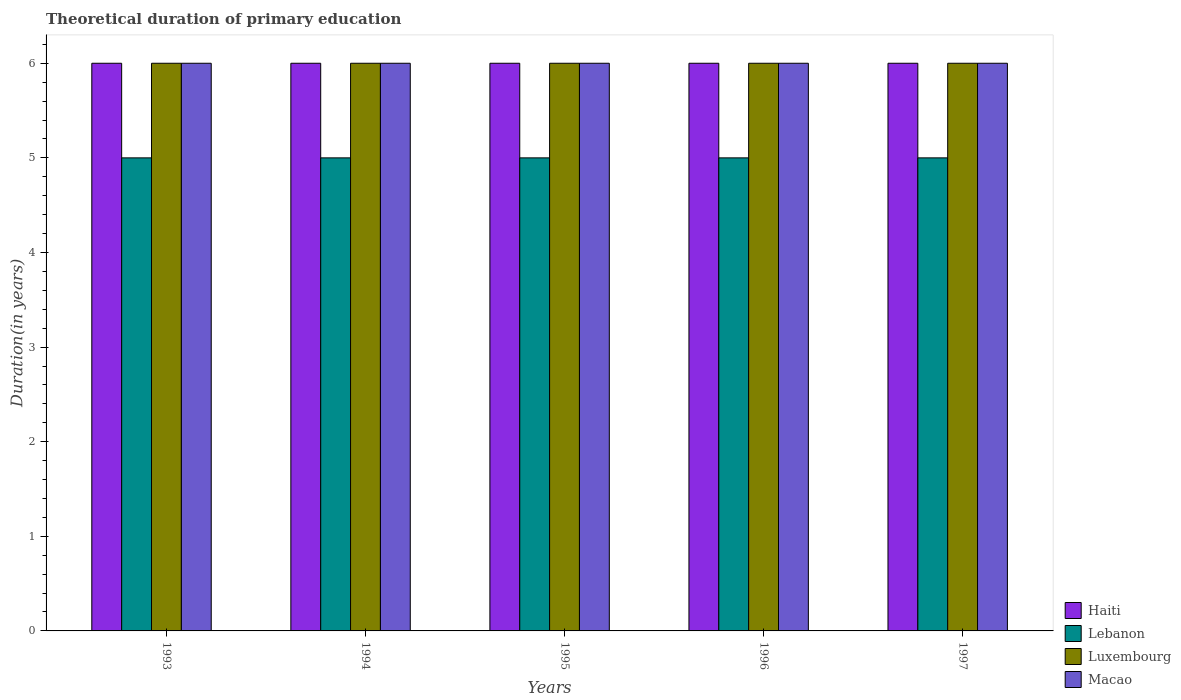How many different coloured bars are there?
Your answer should be compact. 4. How many groups of bars are there?
Provide a short and direct response. 5. Are the number of bars on each tick of the X-axis equal?
Offer a very short reply. Yes. What is the label of the 5th group of bars from the left?
Keep it short and to the point. 1997. What is the total theoretical duration of primary education in Macao in 1993?
Ensure brevity in your answer.  6. Across all years, what is the maximum total theoretical duration of primary education in Lebanon?
Keep it short and to the point. 5. Across all years, what is the minimum total theoretical duration of primary education in Luxembourg?
Your answer should be very brief. 6. In which year was the total theoretical duration of primary education in Haiti maximum?
Your response must be concise. 1993. In which year was the total theoretical duration of primary education in Macao minimum?
Give a very brief answer. 1993. What is the total total theoretical duration of primary education in Macao in the graph?
Your response must be concise. 30. What is the difference between the total theoretical duration of primary education in Luxembourg in 1994 and that in 1997?
Ensure brevity in your answer.  0. What is the average total theoretical duration of primary education in Macao per year?
Make the answer very short. 6. In the year 1994, what is the difference between the total theoretical duration of primary education in Luxembourg and total theoretical duration of primary education in Macao?
Ensure brevity in your answer.  0. In how many years, is the total theoretical duration of primary education in Luxembourg greater than 3.8 years?
Offer a terse response. 5. What is the ratio of the total theoretical duration of primary education in Haiti in 1995 to that in 1997?
Ensure brevity in your answer.  1. Is the total theoretical duration of primary education in Macao in 1993 less than that in 1996?
Provide a succinct answer. No. What is the difference between the highest and the lowest total theoretical duration of primary education in Luxembourg?
Offer a terse response. 0. Is the sum of the total theoretical duration of primary education in Macao in 1994 and 1997 greater than the maximum total theoretical duration of primary education in Haiti across all years?
Your answer should be compact. Yes. Is it the case that in every year, the sum of the total theoretical duration of primary education in Luxembourg and total theoretical duration of primary education in Lebanon is greater than the sum of total theoretical duration of primary education in Haiti and total theoretical duration of primary education in Macao?
Your response must be concise. No. What does the 3rd bar from the left in 1997 represents?
Ensure brevity in your answer.  Luxembourg. What does the 3rd bar from the right in 1993 represents?
Ensure brevity in your answer.  Lebanon. Are all the bars in the graph horizontal?
Your response must be concise. No. Does the graph contain grids?
Provide a succinct answer. No. Where does the legend appear in the graph?
Your answer should be compact. Bottom right. How are the legend labels stacked?
Provide a short and direct response. Vertical. What is the title of the graph?
Your answer should be compact. Theoretical duration of primary education. Does "Bangladesh" appear as one of the legend labels in the graph?
Your answer should be compact. No. What is the label or title of the Y-axis?
Your answer should be compact. Duration(in years). What is the Duration(in years) of Haiti in 1993?
Make the answer very short. 6. What is the Duration(in years) of Lebanon in 1993?
Ensure brevity in your answer.  5. What is the Duration(in years) of Luxembourg in 1993?
Offer a terse response. 6. What is the Duration(in years) of Macao in 1993?
Provide a short and direct response. 6. What is the Duration(in years) of Haiti in 1994?
Give a very brief answer. 6. What is the Duration(in years) in Lebanon in 1994?
Offer a very short reply. 5. What is the Duration(in years) in Macao in 1994?
Ensure brevity in your answer.  6. What is the Duration(in years) of Luxembourg in 1995?
Provide a succinct answer. 6. What is the Duration(in years) of Haiti in 1996?
Make the answer very short. 6. What is the Duration(in years) of Luxembourg in 1996?
Provide a succinct answer. 6. What is the Duration(in years) of Haiti in 1997?
Your answer should be very brief. 6. What is the Duration(in years) of Lebanon in 1997?
Keep it short and to the point. 5. What is the Duration(in years) of Luxembourg in 1997?
Your answer should be very brief. 6. Across all years, what is the maximum Duration(in years) in Haiti?
Ensure brevity in your answer.  6. Across all years, what is the maximum Duration(in years) of Lebanon?
Make the answer very short. 5. Across all years, what is the minimum Duration(in years) in Luxembourg?
Provide a short and direct response. 6. Across all years, what is the minimum Duration(in years) in Macao?
Provide a succinct answer. 6. What is the total Duration(in years) in Luxembourg in the graph?
Give a very brief answer. 30. What is the difference between the Duration(in years) in Haiti in 1993 and that in 1994?
Your answer should be very brief. 0. What is the difference between the Duration(in years) in Haiti in 1993 and that in 1995?
Give a very brief answer. 0. What is the difference between the Duration(in years) in Macao in 1993 and that in 1995?
Provide a succinct answer. 0. What is the difference between the Duration(in years) of Lebanon in 1993 and that in 1996?
Make the answer very short. 0. What is the difference between the Duration(in years) of Luxembourg in 1993 and that in 1996?
Offer a terse response. 0. What is the difference between the Duration(in years) of Lebanon in 1993 and that in 1997?
Offer a very short reply. 0. What is the difference between the Duration(in years) in Macao in 1993 and that in 1997?
Provide a short and direct response. 0. What is the difference between the Duration(in years) of Haiti in 1994 and that in 1995?
Make the answer very short. 0. What is the difference between the Duration(in years) in Lebanon in 1994 and that in 1995?
Your answer should be very brief. 0. What is the difference between the Duration(in years) of Luxembourg in 1994 and that in 1995?
Your answer should be very brief. 0. What is the difference between the Duration(in years) of Luxembourg in 1994 and that in 1997?
Give a very brief answer. 0. What is the difference between the Duration(in years) of Haiti in 1995 and that in 1996?
Ensure brevity in your answer.  0. What is the difference between the Duration(in years) of Luxembourg in 1995 and that in 1996?
Offer a very short reply. 0. What is the difference between the Duration(in years) in Macao in 1995 and that in 1996?
Your answer should be compact. 0. What is the difference between the Duration(in years) of Haiti in 1995 and that in 1997?
Offer a very short reply. 0. What is the difference between the Duration(in years) of Luxembourg in 1995 and that in 1997?
Offer a very short reply. 0. What is the difference between the Duration(in years) in Haiti in 1996 and that in 1997?
Your response must be concise. 0. What is the difference between the Duration(in years) in Lebanon in 1996 and that in 1997?
Your response must be concise. 0. What is the difference between the Duration(in years) of Luxembourg in 1996 and that in 1997?
Your response must be concise. 0. What is the difference between the Duration(in years) of Haiti in 1993 and the Duration(in years) of Lebanon in 1994?
Your response must be concise. 1. What is the difference between the Duration(in years) in Haiti in 1993 and the Duration(in years) in Macao in 1994?
Give a very brief answer. 0. What is the difference between the Duration(in years) in Lebanon in 1993 and the Duration(in years) in Luxembourg in 1994?
Your answer should be compact. -1. What is the difference between the Duration(in years) in Haiti in 1993 and the Duration(in years) in Macao in 1995?
Your answer should be very brief. 0. What is the difference between the Duration(in years) in Lebanon in 1993 and the Duration(in years) in Luxembourg in 1995?
Your response must be concise. -1. What is the difference between the Duration(in years) in Lebanon in 1993 and the Duration(in years) in Macao in 1995?
Make the answer very short. -1. What is the difference between the Duration(in years) of Haiti in 1993 and the Duration(in years) of Luxembourg in 1996?
Your response must be concise. 0. What is the difference between the Duration(in years) in Lebanon in 1993 and the Duration(in years) in Luxembourg in 1996?
Provide a short and direct response. -1. What is the difference between the Duration(in years) of Luxembourg in 1993 and the Duration(in years) of Macao in 1996?
Ensure brevity in your answer.  0. What is the difference between the Duration(in years) of Haiti in 1993 and the Duration(in years) of Lebanon in 1997?
Provide a short and direct response. 1. What is the difference between the Duration(in years) of Haiti in 1993 and the Duration(in years) of Luxembourg in 1997?
Give a very brief answer. 0. What is the difference between the Duration(in years) in Lebanon in 1993 and the Duration(in years) in Luxembourg in 1997?
Give a very brief answer. -1. What is the difference between the Duration(in years) of Luxembourg in 1993 and the Duration(in years) of Macao in 1997?
Provide a succinct answer. 0. What is the difference between the Duration(in years) in Haiti in 1994 and the Duration(in years) in Macao in 1995?
Offer a terse response. 0. What is the difference between the Duration(in years) of Lebanon in 1994 and the Duration(in years) of Luxembourg in 1995?
Give a very brief answer. -1. What is the difference between the Duration(in years) of Luxembourg in 1994 and the Duration(in years) of Macao in 1995?
Make the answer very short. 0. What is the difference between the Duration(in years) in Haiti in 1994 and the Duration(in years) in Lebanon in 1996?
Give a very brief answer. 1. What is the difference between the Duration(in years) of Haiti in 1994 and the Duration(in years) of Macao in 1996?
Give a very brief answer. 0. What is the difference between the Duration(in years) of Luxembourg in 1994 and the Duration(in years) of Macao in 1996?
Provide a succinct answer. 0. What is the difference between the Duration(in years) in Haiti in 1994 and the Duration(in years) in Lebanon in 1997?
Give a very brief answer. 1. What is the difference between the Duration(in years) of Haiti in 1994 and the Duration(in years) of Luxembourg in 1997?
Provide a succinct answer. 0. What is the difference between the Duration(in years) in Lebanon in 1994 and the Duration(in years) in Luxembourg in 1997?
Keep it short and to the point. -1. What is the difference between the Duration(in years) of Lebanon in 1994 and the Duration(in years) of Macao in 1997?
Offer a very short reply. -1. What is the difference between the Duration(in years) in Haiti in 1995 and the Duration(in years) in Luxembourg in 1996?
Offer a very short reply. 0. What is the difference between the Duration(in years) of Haiti in 1995 and the Duration(in years) of Macao in 1996?
Give a very brief answer. 0. What is the difference between the Duration(in years) of Haiti in 1995 and the Duration(in years) of Luxembourg in 1997?
Make the answer very short. 0. What is the difference between the Duration(in years) of Haiti in 1995 and the Duration(in years) of Macao in 1997?
Your answer should be very brief. 0. What is the difference between the Duration(in years) in Luxembourg in 1995 and the Duration(in years) in Macao in 1997?
Your answer should be very brief. 0. What is the difference between the Duration(in years) in Haiti in 1996 and the Duration(in years) in Lebanon in 1997?
Offer a terse response. 1. What is the difference between the Duration(in years) of Haiti in 1996 and the Duration(in years) of Luxembourg in 1997?
Your answer should be very brief. 0. What is the difference between the Duration(in years) of Luxembourg in 1996 and the Duration(in years) of Macao in 1997?
Provide a short and direct response. 0. What is the average Duration(in years) in Haiti per year?
Your answer should be very brief. 6. What is the average Duration(in years) in Lebanon per year?
Make the answer very short. 5. What is the average Duration(in years) of Luxembourg per year?
Provide a succinct answer. 6. In the year 1993, what is the difference between the Duration(in years) of Lebanon and Duration(in years) of Luxembourg?
Give a very brief answer. -1. In the year 1994, what is the difference between the Duration(in years) in Haiti and Duration(in years) in Lebanon?
Offer a very short reply. 1. In the year 1994, what is the difference between the Duration(in years) in Lebanon and Duration(in years) in Luxembourg?
Your answer should be compact. -1. In the year 1994, what is the difference between the Duration(in years) in Lebanon and Duration(in years) in Macao?
Offer a terse response. -1. In the year 1995, what is the difference between the Duration(in years) in Haiti and Duration(in years) in Luxembourg?
Provide a short and direct response. 0. In the year 1996, what is the difference between the Duration(in years) in Haiti and Duration(in years) in Lebanon?
Offer a very short reply. 1. In the year 1996, what is the difference between the Duration(in years) of Haiti and Duration(in years) of Macao?
Give a very brief answer. 0. In the year 1996, what is the difference between the Duration(in years) in Lebanon and Duration(in years) in Macao?
Keep it short and to the point. -1. In the year 1997, what is the difference between the Duration(in years) in Lebanon and Duration(in years) in Luxembourg?
Your answer should be very brief. -1. In the year 1997, what is the difference between the Duration(in years) in Luxembourg and Duration(in years) in Macao?
Provide a short and direct response. 0. What is the ratio of the Duration(in years) of Haiti in 1993 to that in 1995?
Your answer should be compact. 1. What is the ratio of the Duration(in years) in Lebanon in 1993 to that in 1995?
Your answer should be very brief. 1. What is the ratio of the Duration(in years) of Lebanon in 1993 to that in 1996?
Your response must be concise. 1. What is the ratio of the Duration(in years) of Luxembourg in 1993 to that in 1996?
Your answer should be compact. 1. What is the ratio of the Duration(in years) of Haiti in 1994 to that in 1995?
Make the answer very short. 1. What is the ratio of the Duration(in years) of Lebanon in 1994 to that in 1995?
Give a very brief answer. 1. What is the ratio of the Duration(in years) in Luxembourg in 1994 to that in 1995?
Offer a very short reply. 1. What is the ratio of the Duration(in years) in Macao in 1994 to that in 1995?
Offer a very short reply. 1. What is the ratio of the Duration(in years) of Lebanon in 1994 to that in 1996?
Your answer should be very brief. 1. What is the ratio of the Duration(in years) in Macao in 1994 to that in 1996?
Provide a short and direct response. 1. What is the ratio of the Duration(in years) in Haiti in 1994 to that in 1997?
Offer a terse response. 1. What is the ratio of the Duration(in years) in Luxembourg in 1994 to that in 1997?
Offer a terse response. 1. What is the ratio of the Duration(in years) of Macao in 1994 to that in 1997?
Keep it short and to the point. 1. What is the ratio of the Duration(in years) in Haiti in 1995 to that in 1996?
Your response must be concise. 1. What is the ratio of the Duration(in years) in Luxembourg in 1995 to that in 1996?
Your answer should be compact. 1. What is the ratio of the Duration(in years) of Macao in 1995 to that in 1996?
Offer a terse response. 1. What is the ratio of the Duration(in years) of Haiti in 1995 to that in 1997?
Give a very brief answer. 1. What is the ratio of the Duration(in years) of Luxembourg in 1995 to that in 1997?
Your answer should be very brief. 1. What is the ratio of the Duration(in years) in Macao in 1996 to that in 1997?
Offer a terse response. 1. What is the difference between the highest and the second highest Duration(in years) in Lebanon?
Offer a very short reply. 0. What is the difference between the highest and the second highest Duration(in years) of Macao?
Offer a terse response. 0. What is the difference between the highest and the lowest Duration(in years) of Haiti?
Make the answer very short. 0. What is the difference between the highest and the lowest Duration(in years) of Lebanon?
Your response must be concise. 0. What is the difference between the highest and the lowest Duration(in years) of Luxembourg?
Your answer should be very brief. 0. What is the difference between the highest and the lowest Duration(in years) of Macao?
Make the answer very short. 0. 